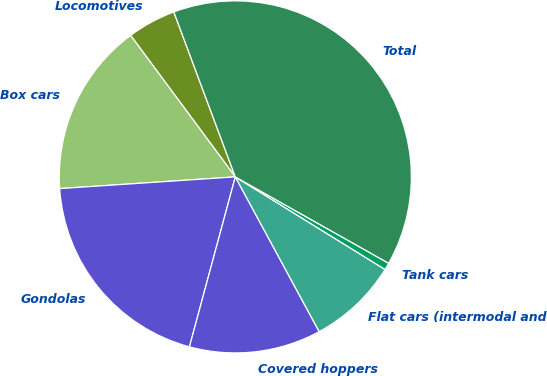Convert chart. <chart><loc_0><loc_0><loc_500><loc_500><pie_chart><fcel>Locomotives<fcel>Box cars<fcel>Gondolas<fcel>Covered hoppers<fcel>Flat cars (intermodal and<fcel>Tank cars<fcel>Total<nl><fcel>4.46%<fcel>15.92%<fcel>19.74%<fcel>12.1%<fcel>8.28%<fcel>0.65%<fcel>38.84%<nl></chart> 